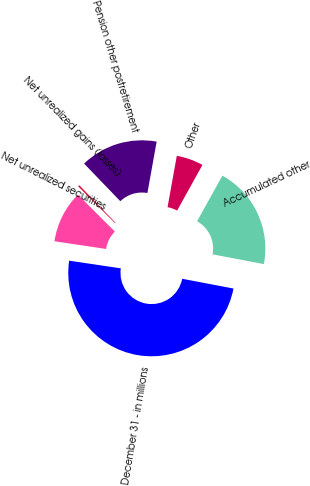Convert chart. <chart><loc_0><loc_0><loc_500><loc_500><pie_chart><fcel>December 31 - in millions<fcel>Net unrealized securities<fcel>Net unrealized gains (losses)<fcel>Pension other postretirement<fcel>Other<fcel>Accumulated other<nl><fcel>49.36%<fcel>10.13%<fcel>0.32%<fcel>15.03%<fcel>5.22%<fcel>19.94%<nl></chart> 